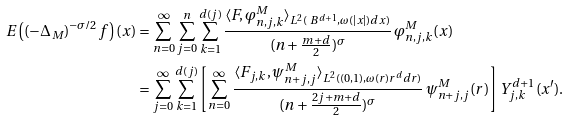<formula> <loc_0><loc_0><loc_500><loc_500>E \left ( ( - \Delta _ { M } ) ^ { - \sigma / 2 } f \right ) ( x ) & = \sum _ { n = 0 } ^ { \infty } \sum _ { j = 0 } ^ { n } \sum _ { k = 1 } ^ { d ( j ) } \frac { \langle F , \varphi ^ { M } _ { n , j , k } \rangle _ { L ^ { 2 } ( \ B ^ { d + 1 } , \omega ( | x | ) d x ) } } { ( n + \frac { m + d } { 2 } ) ^ { \sigma } } \, \varphi _ { n , j , k } ^ { M } ( x ) \\ & = \sum _ { j = 0 } ^ { \infty } \sum _ { k = 1 } ^ { d ( j ) } \left [ \sum _ { n = 0 } ^ { \infty } \frac { \langle F _ { j , k } , \psi ^ { M } _ { n + j , j } \rangle _ { L ^ { 2 } ( ( 0 , 1 ) , \omega ( r ) r ^ { d } d r ) } } { ( n + \frac { 2 j + m + d } { 2 } ) ^ { \sigma } } \, \psi ^ { M } _ { n + j , j } ( r ) \right ] Y ^ { d + 1 } _ { j , k } ( x ^ { \prime } ) . \\</formula> 